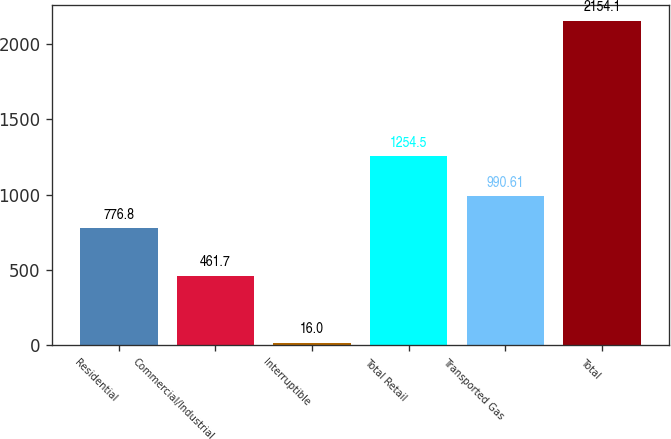<chart> <loc_0><loc_0><loc_500><loc_500><bar_chart><fcel>Residential<fcel>Commercial/Industrial<fcel>Interruptible<fcel>Total Retail<fcel>Transported Gas<fcel>Total<nl><fcel>776.8<fcel>461.7<fcel>16<fcel>1254.5<fcel>990.61<fcel>2154.1<nl></chart> 